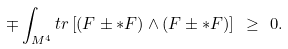<formula> <loc_0><loc_0><loc_500><loc_500>\mp \int _ { M ^ { 4 } } t r \left [ ( F \pm { * F } ) \wedge ( F \pm { * F } ) \right ] \ \geq \ 0 .</formula> 